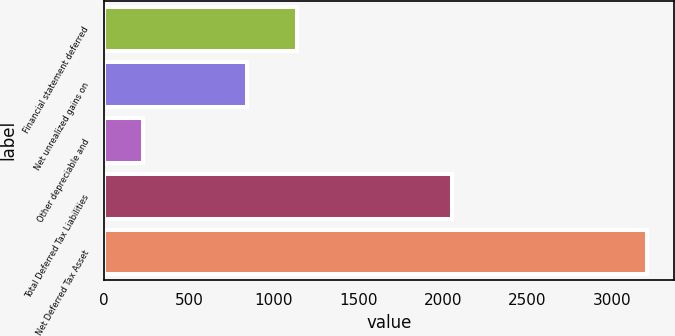Convert chart to OTSL. <chart><loc_0><loc_0><loc_500><loc_500><bar_chart><fcel>Financial statement deferred<fcel>Net unrealized gains on<fcel>Other depreciable and<fcel>Total Deferred Tax Liabilities<fcel>Net Deferred Tax Asset<nl><fcel>1139.7<fcel>842<fcel>229<fcel>2056<fcel>3206<nl></chart> 